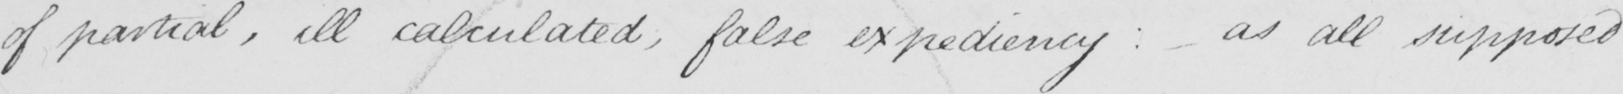What is written in this line of handwriting? of partial , ill calculated , false expediency :  as all supposed 